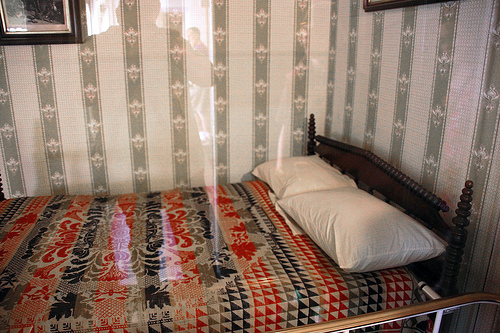What mood does the lighting in the room evoke? The lighting in the room evokes a warm, nostalgic mood with soft illumination filtering through the window and reflecting off the quilt and walls. It creates a cozy and inviting atmosphere, ideal for a serene bedroom setting. 